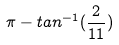<formula> <loc_0><loc_0><loc_500><loc_500>\pi - t a n ^ { - 1 } ( \frac { 2 } { 1 1 } )</formula> 